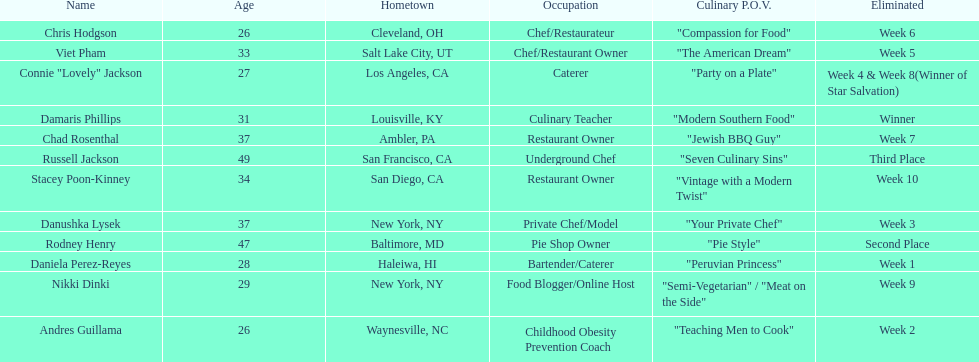Which competitor only lasted two weeks? Andres Guillama. 